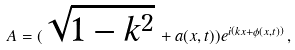<formula> <loc_0><loc_0><loc_500><loc_500>A = ( \sqrt { 1 - k ^ { 2 } } \, + a ( x , t ) ) e ^ { i \left ( k x + \phi ( x , t ) \right ) } \, ,</formula> 